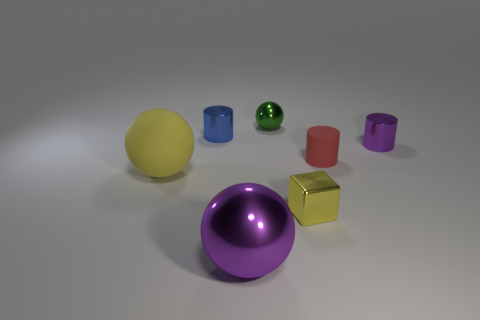Subtract all red cylinders. How many cylinders are left? 2 Add 2 small shiny cubes. How many objects exist? 9 Subtract all blocks. How many objects are left? 6 Subtract 0 blue balls. How many objects are left? 7 Subtract all large metallic balls. Subtract all red cylinders. How many objects are left? 5 Add 1 big yellow objects. How many big yellow objects are left? 2 Add 7 tiny blue matte balls. How many tiny blue matte balls exist? 7 